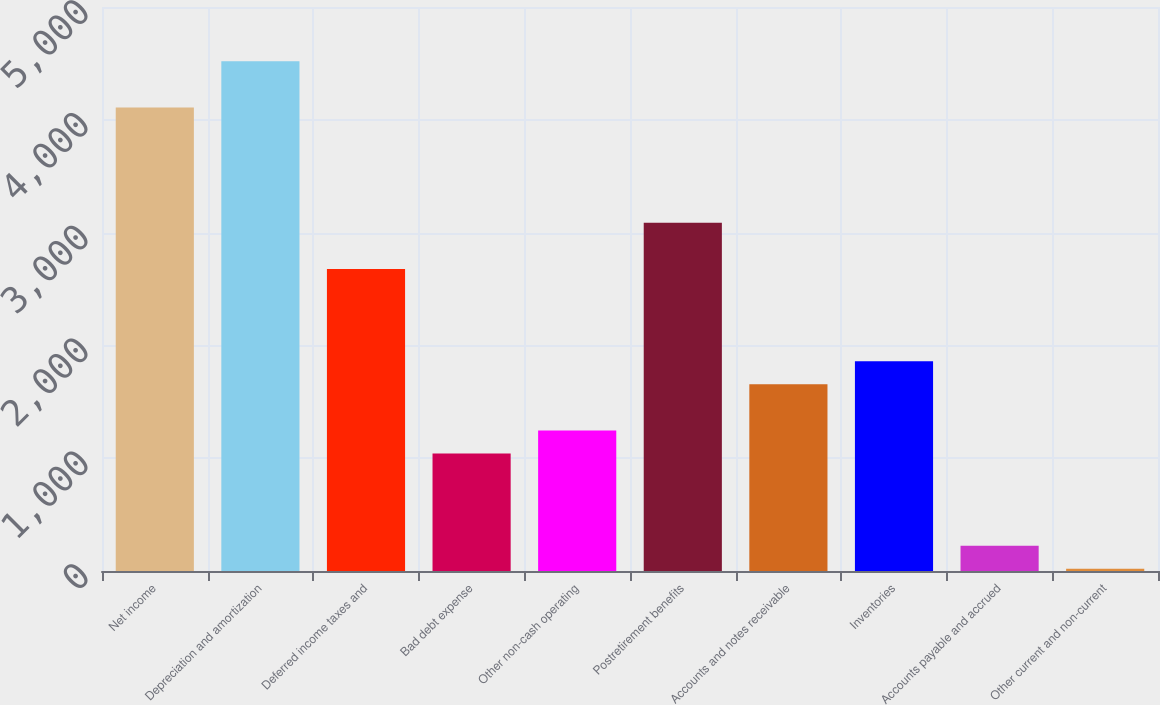Convert chart. <chart><loc_0><loc_0><loc_500><loc_500><bar_chart><fcel>Net income<fcel>Depreciation and amortization<fcel>Deferred income taxes and<fcel>Bad debt expense<fcel>Other non-cash operating<fcel>Postretirement benefits<fcel>Accounts and notes receivable<fcel>Inventories<fcel>Accounts payable and accrued<fcel>Other current and non-current<nl><fcel>4109<fcel>4518<fcel>2677.5<fcel>1041.5<fcel>1246<fcel>3086.5<fcel>1655<fcel>1859.5<fcel>223.5<fcel>19<nl></chart> 